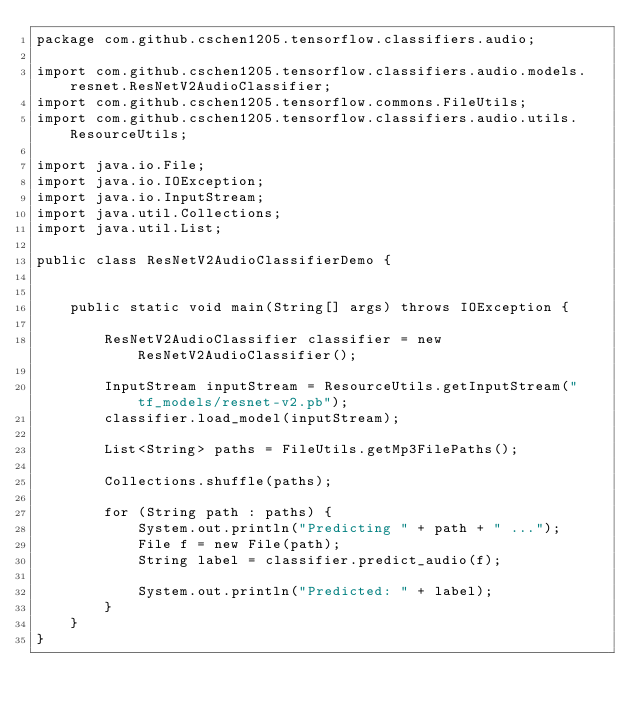Convert code to text. <code><loc_0><loc_0><loc_500><loc_500><_Java_>package com.github.cschen1205.tensorflow.classifiers.audio;

import com.github.cschen1205.tensorflow.classifiers.audio.models.resnet.ResNetV2AudioClassifier;
import com.github.cschen1205.tensorflow.commons.FileUtils;
import com.github.cschen1205.tensorflow.classifiers.audio.utils.ResourceUtils;

import java.io.File;
import java.io.IOException;
import java.io.InputStream;
import java.util.Collections;
import java.util.List;

public class ResNetV2AudioClassifierDemo {


    public static void main(String[] args) throws IOException {

        ResNetV2AudioClassifier classifier = new ResNetV2AudioClassifier();

        InputStream inputStream = ResourceUtils.getInputStream("tf_models/resnet-v2.pb");
        classifier.load_model(inputStream);

        List<String> paths = FileUtils.getMp3FilePaths();

        Collections.shuffle(paths);

        for (String path : paths) {
            System.out.println("Predicting " + path + " ...");
            File f = new File(path);
            String label = classifier.predict_audio(f);

            System.out.println("Predicted: " + label);
        }
    }
}
</code> 